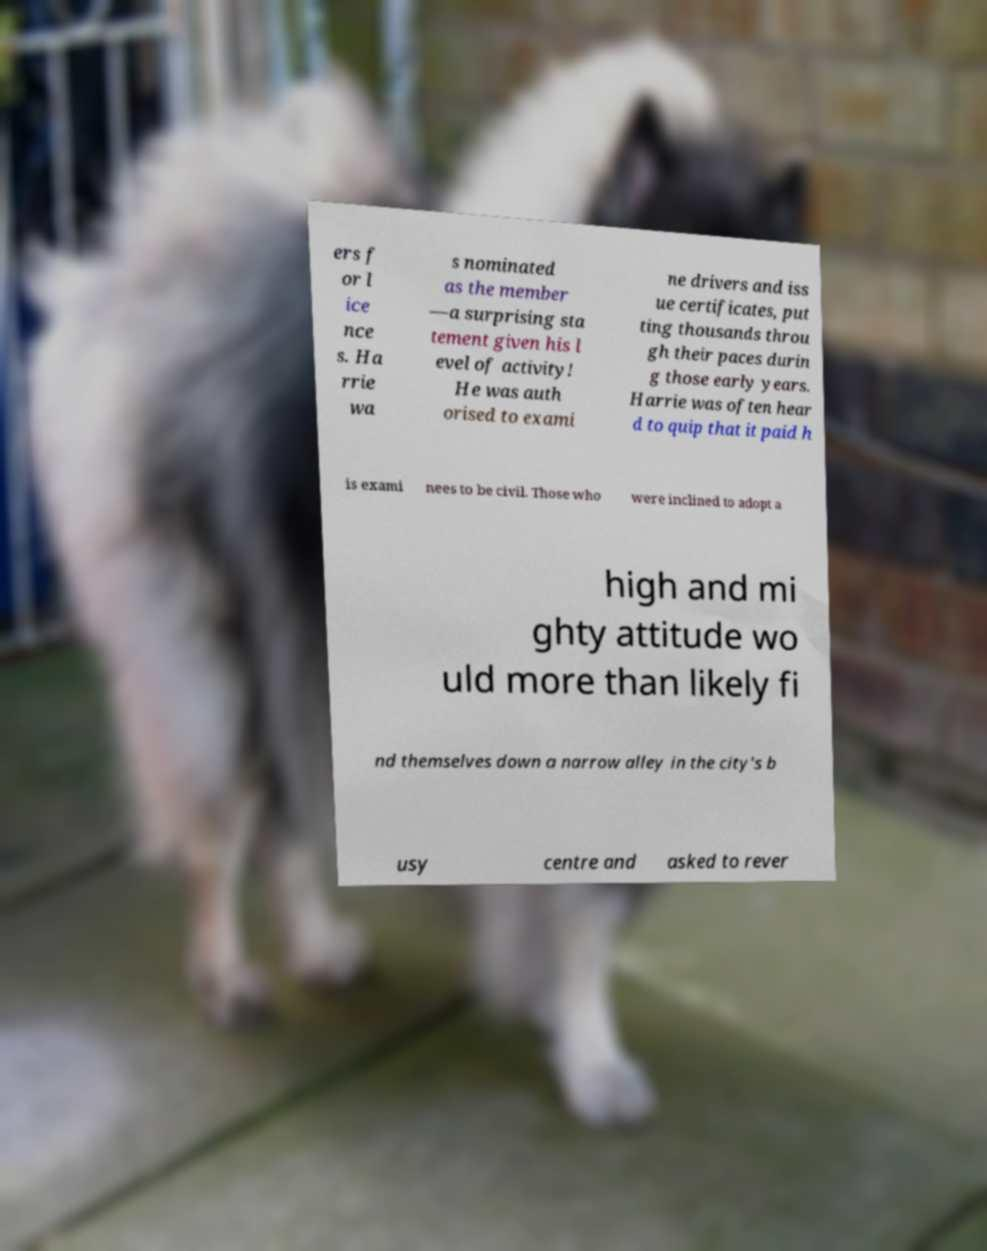For documentation purposes, I need the text within this image transcribed. Could you provide that? ers f or l ice nce s. Ha rrie wa s nominated as the member —a surprising sta tement given his l evel of activity! He was auth orised to exami ne drivers and iss ue certificates, put ting thousands throu gh their paces durin g those early years. Harrie was often hear d to quip that it paid h is exami nees to be civil. Those who were inclined to adopt a high and mi ghty attitude wo uld more than likely fi nd themselves down a narrow alley in the city's b usy centre and asked to rever 